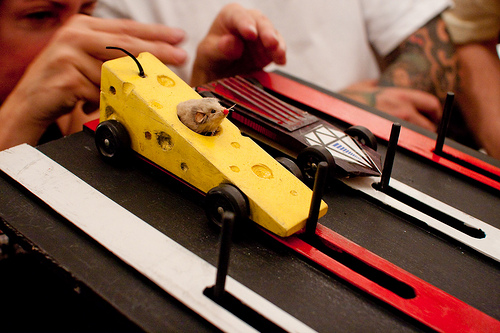<image>
Is the mouse in the cheese? Yes. The mouse is contained within or inside the cheese, showing a containment relationship. Is there a wheel on the car? Yes. Looking at the image, I can see the wheel is positioned on top of the car, with the car providing support. 